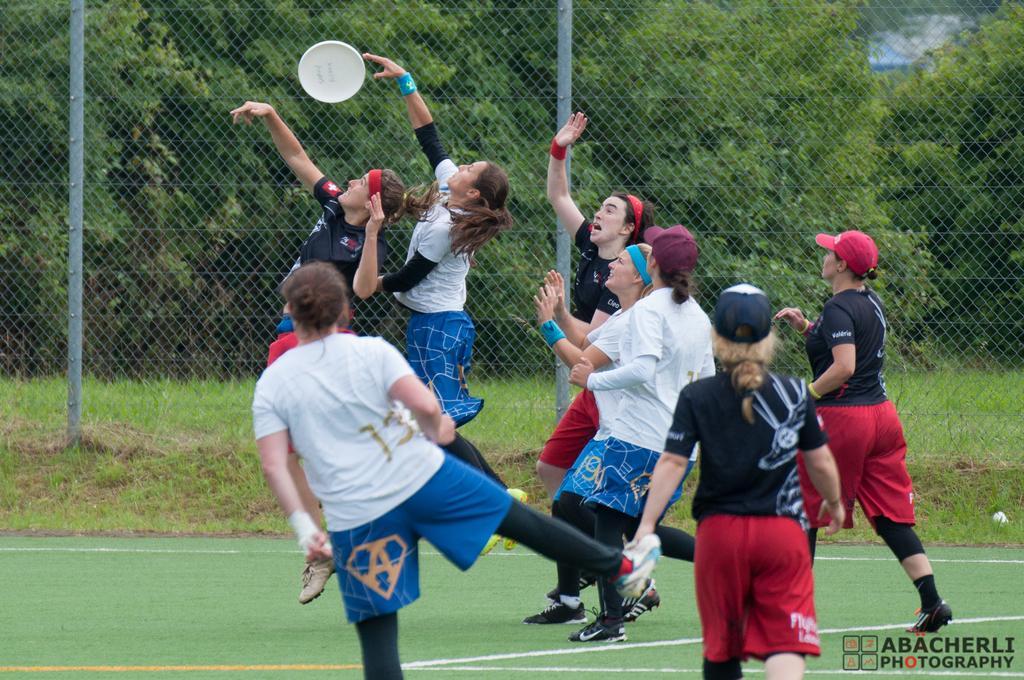Can you describe this image briefly? In this image we can see one white color object looks like a disc near the fence, some people playing on the ground, one fence, one object on the ground on the right side of the image, two objects on the top right side of the image, some trees in the background, some grass on the ground, some text and images on the bottom right side of the image. 